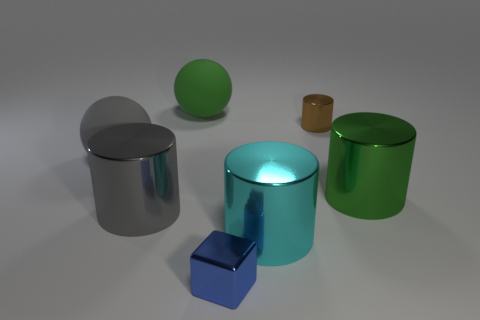What number of small cyan cubes are there?
Offer a terse response. 0. There is a big ball right of the big gray object in front of the large shiny thing that is on the right side of the tiny brown cylinder; what is its material?
Your answer should be very brief. Rubber. What number of big metallic objects are to the right of the big rubber sphere that is on the left side of the green rubber ball?
Offer a terse response. 3. There is a tiny metal thing that is the same shape as the big cyan metal thing; what color is it?
Provide a succinct answer. Brown. Is the small brown cylinder made of the same material as the small blue cube?
Your answer should be compact. Yes. What number of spheres are brown objects or big green objects?
Ensure brevity in your answer.  1. There is a sphere to the left of the big gray metallic object that is on the left side of the small shiny thing behind the big gray metal cylinder; what size is it?
Provide a short and direct response. Large. The green object that is the same shape as the large gray rubber object is what size?
Provide a succinct answer. Large. How many gray cylinders are to the right of the cyan thing?
Give a very brief answer. 0. There is a small object on the right side of the big cyan object; is its color the same as the tiny shiny block?
Make the answer very short. No. 